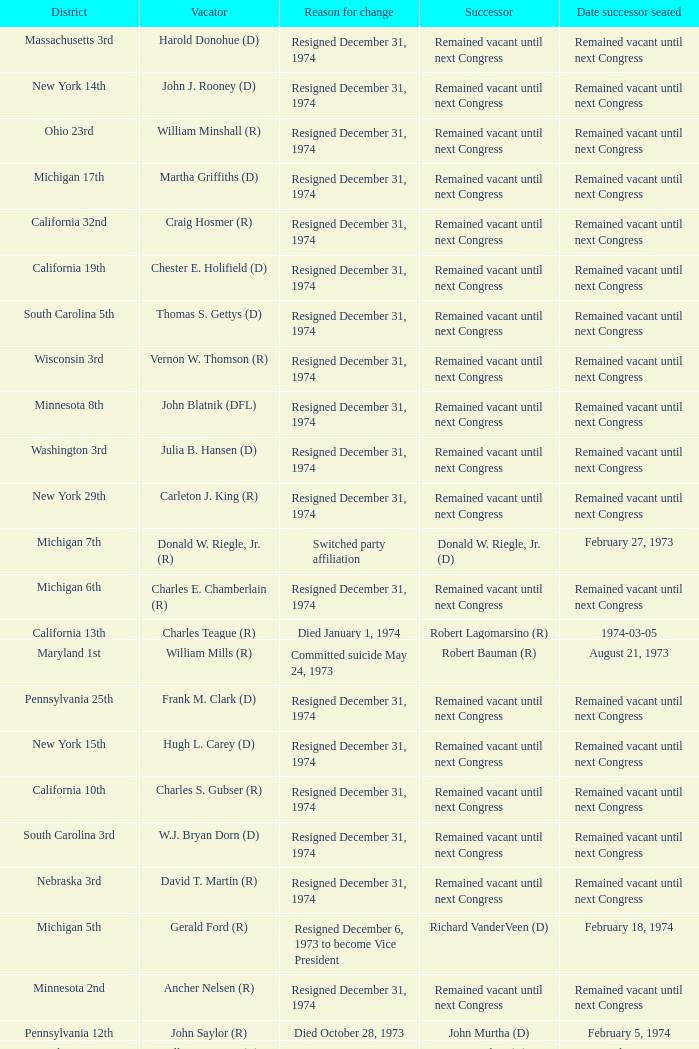What was the district when the reason for change was died January 1, 1974? California 13th. 